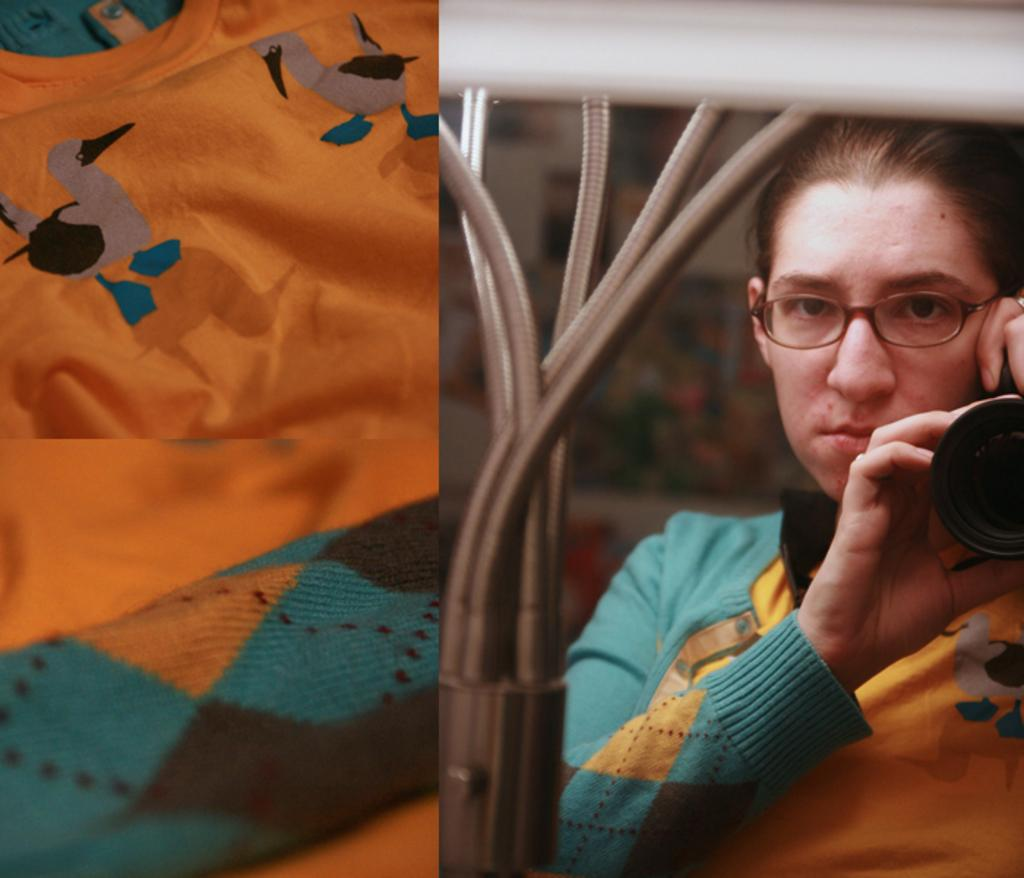Who is the main subject in the image? There is a woman in the image. What is the woman holding in the image? The woman is holding a camera. What accessory is the woman wearing in the image? The woman is wearing specs. Can you describe any other objects visible in the image? There is a cloth visible in the image. What type of nut can be seen growing on the bushes in the image? There are no bushes or nuts present in the image; it features a woman holding a camera and wearing specs, along with a cloth. 